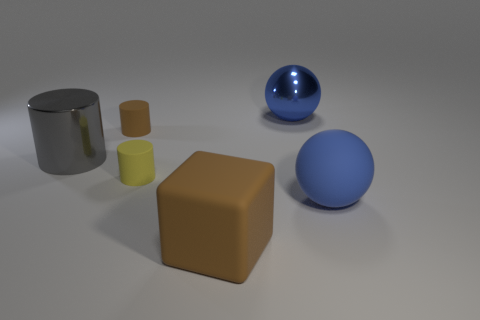How many other objects are there of the same color as the big cylinder?
Give a very brief answer. 0. Is the number of objects that are on the left side of the tiny yellow rubber cylinder greater than the number of blue metal spheres?
Your answer should be very brief. Yes. What color is the large metallic object that is right of the metallic object that is to the left of the brown object in front of the big gray cylinder?
Provide a succinct answer. Blue. Is the brown cylinder made of the same material as the cube?
Offer a terse response. Yes. Is there a cube that has the same size as the yellow thing?
Offer a terse response. No. What material is the brown cube that is the same size as the gray metallic object?
Ensure brevity in your answer.  Rubber. Is there a small purple rubber object of the same shape as the blue metal thing?
Give a very brief answer. No. There is a tiny object that is the same color as the matte cube; what material is it?
Your answer should be very brief. Rubber. What is the shape of the metallic object that is behind the gray cylinder?
Offer a terse response. Sphere. How many large blue rubber things are there?
Your answer should be very brief. 1. 